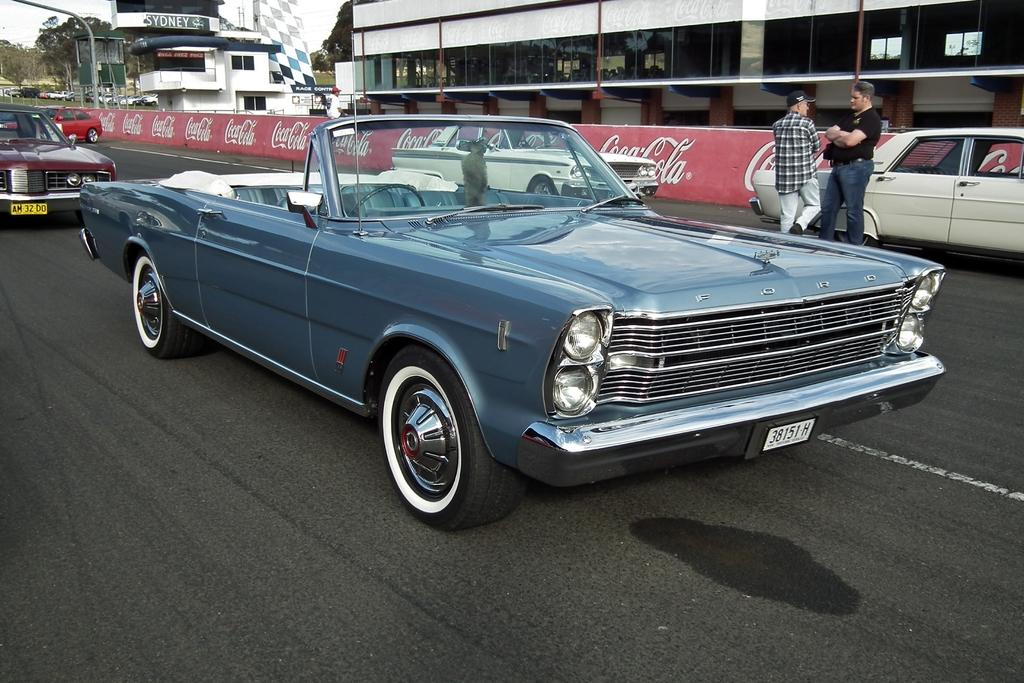What are the people in the image doing? The persons in the image are standing on the road. What else can be seen on the road besides the people? Motor vehicles are present in the image. What type of signage is visible in the image? Advertisement boards are visible in the image. What type of structures are present in the image? There are buildings in the image. What type of vegetation is present in the image? Trees are present in the image. What is visible in the background of the image? The sky is visible in the image. Can you describe the detail of the grandmother's linen in the image? There is no grandmother or linen present in the image. What type of linen is being used to cover the motor vehicles in the image? There is no linen covering the motor vehicles in the image; they are not covered at all. 